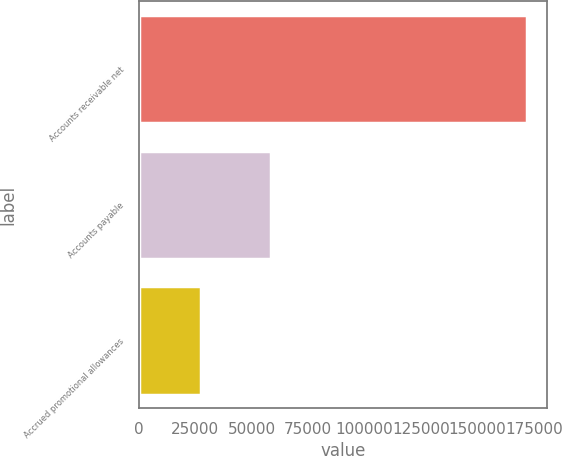<chart> <loc_0><loc_0><loc_500><loc_500><bar_chart><fcel>Accounts receivable net<fcel>Accounts payable<fcel>Accrued promotional allowances<nl><fcel>172201<fcel>58579<fcel>27544<nl></chart> 